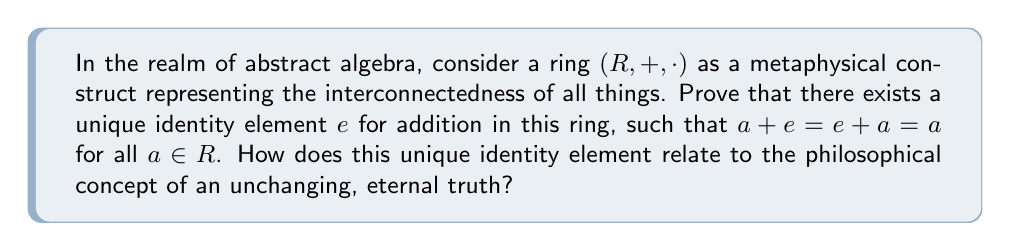Provide a solution to this math problem. To prove the existence and uniqueness of the additive identity element in a ring, we'll follow these steps:

1) Existence:
   Let $a$ be any element in $R$. By the ring axioms, there exists an additive inverse $-a$ such that $a + (-a) = (-a) + a = 0$, where $0$ is some element in $R$.
   
   We claim that this $0$ is the additive identity. To prove this, let $b$ be any element in $R$.
   
   $$b = b + 0 = b + (a + (-a)) = (b + a) + (-a) = (a + b) + (-a) = a + (b + (-a)) = a + ((-a) + b) = (a + (-a)) + b = 0 + b = b$$
   
   Therefore, $b + 0 = 0 + b = b$ for all $b \in R$, proving that $0$ is indeed the additive identity.

2) Uniqueness:
   Suppose there are two additive identity elements, $e$ and $e'$. Then:
   
   $$e = e + e' = e'$$
   
   This proves that the additive identity is unique.

Philosophical interpretation:
The unique additive identity in a ring can be seen as a metaphor for an unchanging, eternal truth in philosophy. Just as the identity element remains constant and unaffected when combined with any other element, fundamental truths in philosophy are often considered immutable and universal, providing a stable foundation for understanding reality.

This concept aligns with Platonic idealism, where abstract forms or ideas are considered the true reality, unchanging and eternal. The unique identity element in a ring structure could be seen as analogous to these perfect, immutable forms in Plato's philosophy.
Answer: The ring $(R, +, \cdot)$ has a unique additive identity element $e$ such that $a + e = e + a = a$ for all $a \in R$. This element is typically denoted as $0$. The uniqueness of this element reflects the philosophical concept of an unchanging, eternal truth, serving as a constant reference point in the abstract structure of the ring, much like fundamental truths serve as unchanging principles in philosophical discourse. 